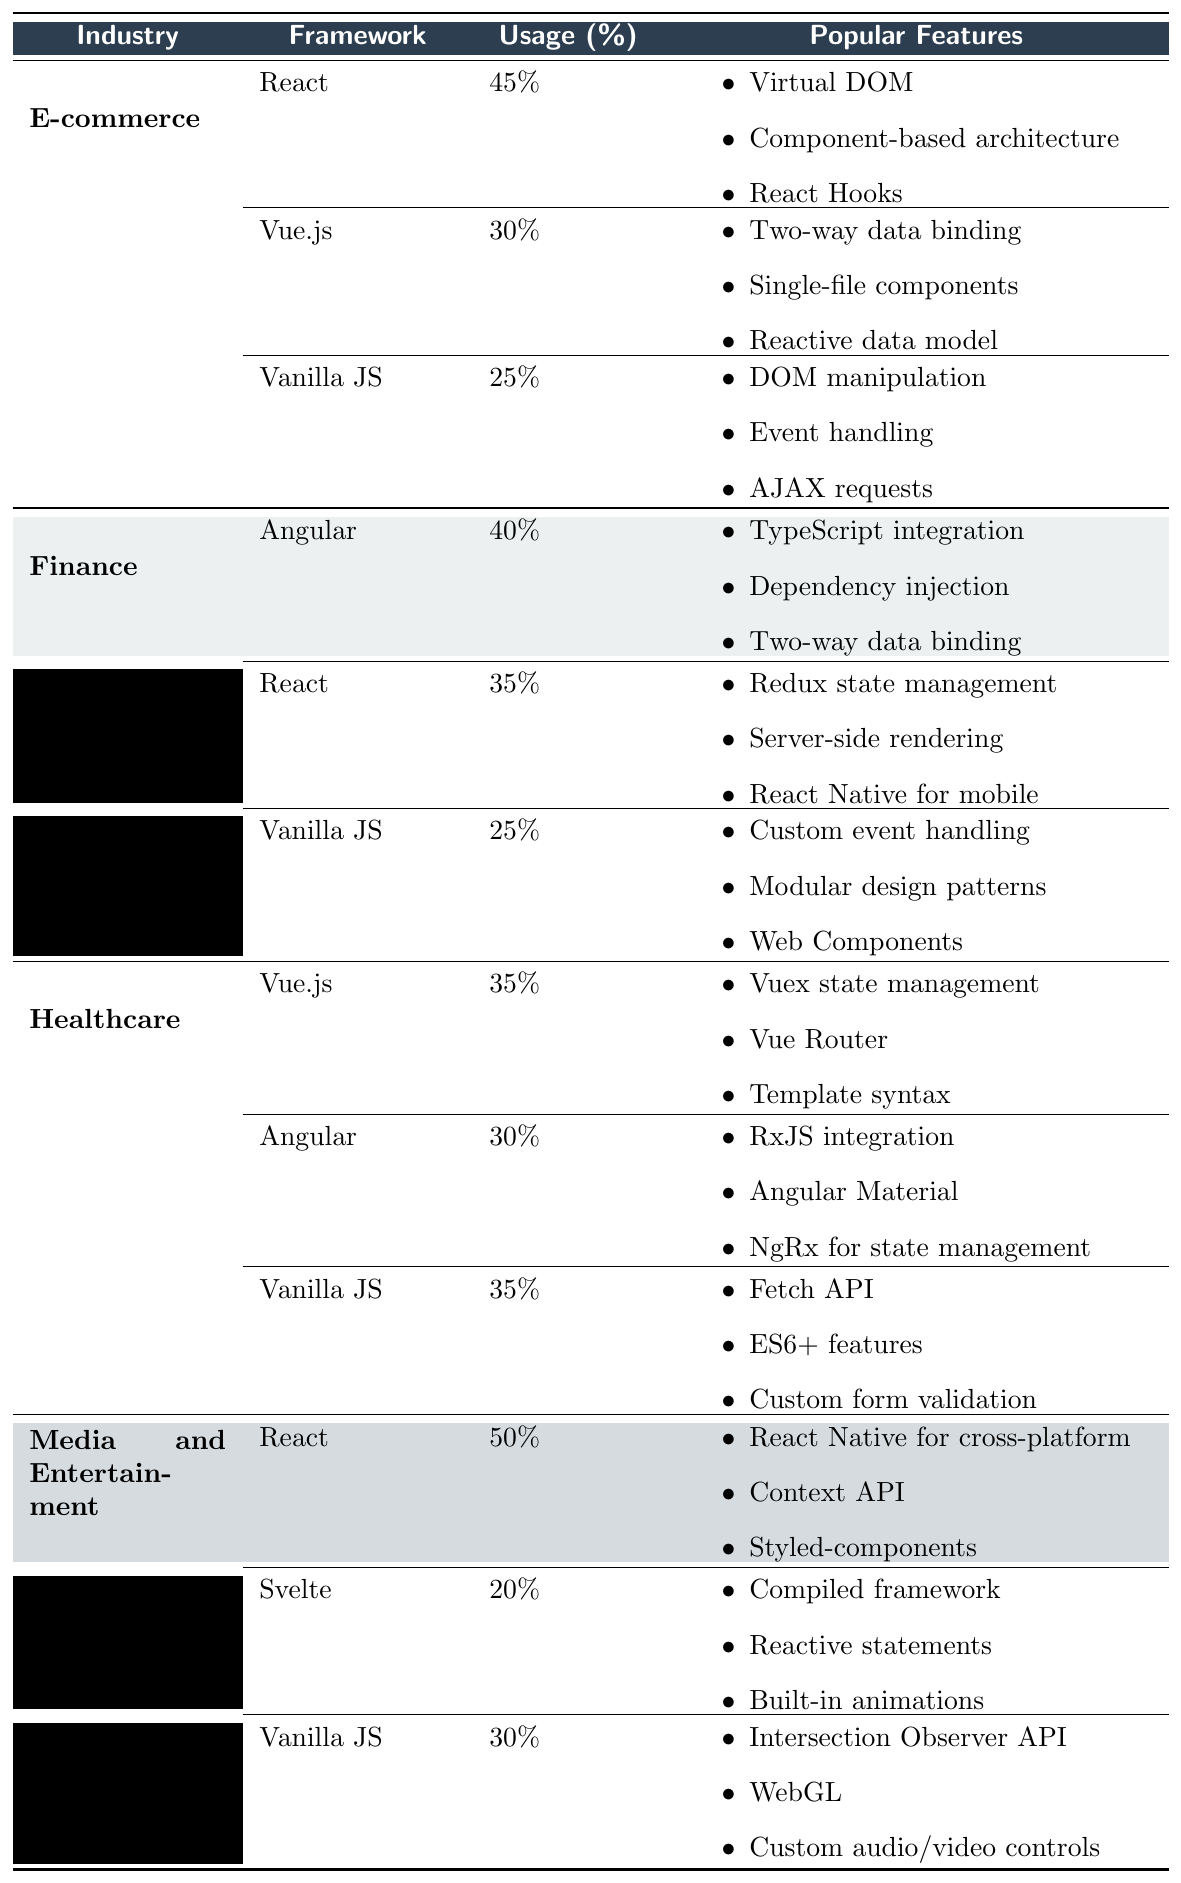What JavaScript framework has the highest usage in the E-commerce industry? In the E-commerce section of the table, React has a usage percentage of 45%, which is higher than Vue.js (30%) and Vanilla JavaScript (25%).
Answer: React Which framework is used the most in the Media and Entertainment industry? The table shows that in the Media and Entertainment industry, React has the highest usage at 50%, compared to Svelte (20%) and Vanilla JavaScript (30%).
Answer: React What is the usage percentage difference between Angular and React in the Finance industry? In the Finance industry, Angular has a usage of 40% and React has 35%. The difference is calculated as 40% - 35% = 5%.
Answer: 5% Which framework has equal usage in both the Healthcare and Finance industries? In both industries, Vanilla JavaScript has a usage percentage of 25% in Finance and 35% in Healthcare, indicating no equal usage. Therefore, there is no framework with equal usage across both industries.
Answer: No What are the popular features of Vue.js in the Healthcare industry? In the Healthcare industry section of the table, the popular features listed for Vue.js include: Vuex state management, Vue Router, and Template syntax.
Answer: Vuex state management, Vue Router, Template syntax What is the total percentage usage of Vanilla JavaScript across all industries listed? To find the total usage, we sum the usage percentages of Vanilla JavaScript: E-commerce (25%) + Finance (25%) + Healthcare (35%) + Media and Entertainment (30%) = 115%.
Answer: 115% In which industry does Angular display the lowest usage percentage? Looking at the table, Angular has the lowest usage percentage in the Media and Entertainment industry, where it is not listed, hence a usage of 0%. In Finance, it is 40% and in Healthcare, it is 30%, thus it is non-applicable in Media and Entertainment.
Answer: Media and Entertainment What percentage of the time is Vanilla JavaScript used compared to React in the E-commerce industry? In the E-commerce industry, React is used 45% of the time and Vanilla JavaScript is used 25% of the time. So, the percentage of Vanilla JavaScript usage compared to React is calculated as (25% / 45%) * 100 = 55.56%.
Answer: 55.56% Which framework is used the least in the Finance industry? From the Finance industry section in the table, Vanilla JavaScript has a usage of 25%, while React has 35% and Angular has 40%. Therefore, Vanilla JavaScript is the least used.
Answer: Vanilla JavaScript How many frameworks have a usage above 30% in the Healthcare industry? Checking the Healthcare section, Vue.js has a usage of 35%, Angular has 30%, and Vanilla JavaScript has 35%. So, Vue.js and Vanilla JavaScript both exceed 30%, resulting in 2 frameworks above this threshold.
Answer: 2 